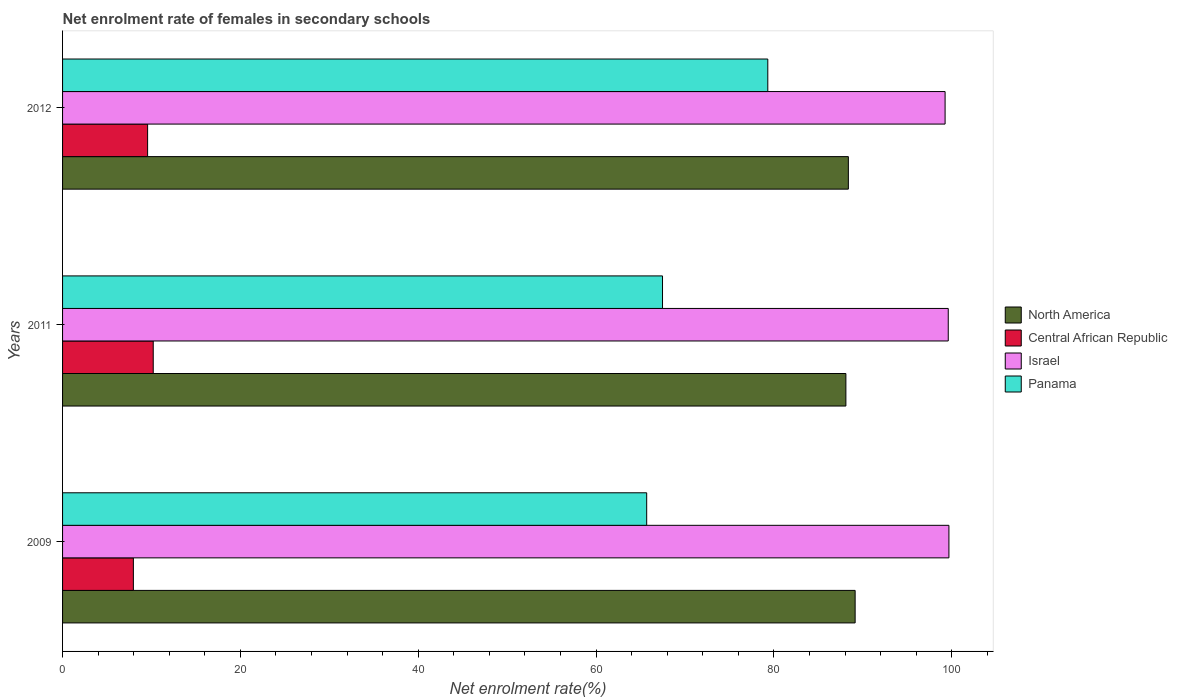How many groups of bars are there?
Your answer should be very brief. 3. Are the number of bars per tick equal to the number of legend labels?
Offer a very short reply. Yes. Are the number of bars on each tick of the Y-axis equal?
Offer a very short reply. Yes. How many bars are there on the 3rd tick from the top?
Your answer should be compact. 4. How many bars are there on the 2nd tick from the bottom?
Provide a short and direct response. 4. What is the label of the 2nd group of bars from the top?
Offer a very short reply. 2011. In how many cases, is the number of bars for a given year not equal to the number of legend labels?
Your response must be concise. 0. What is the net enrolment rate of females in secondary schools in North America in 2012?
Keep it short and to the point. 88.38. Across all years, what is the maximum net enrolment rate of females in secondary schools in Central African Republic?
Ensure brevity in your answer.  10.2. Across all years, what is the minimum net enrolment rate of females in secondary schools in Israel?
Make the answer very short. 99.26. What is the total net enrolment rate of females in secondary schools in Panama in the graph?
Provide a short and direct response. 212.49. What is the difference between the net enrolment rate of females in secondary schools in North America in 2009 and that in 2012?
Ensure brevity in your answer.  0.76. What is the difference between the net enrolment rate of females in secondary schools in Israel in 2009 and the net enrolment rate of females in secondary schools in North America in 2012?
Ensure brevity in your answer.  11.31. What is the average net enrolment rate of females in secondary schools in Central African Republic per year?
Keep it short and to the point. 9.24. In the year 2011, what is the difference between the net enrolment rate of females in secondary schools in North America and net enrolment rate of females in secondary schools in Central African Republic?
Your answer should be compact. 77.9. In how many years, is the net enrolment rate of females in secondary schools in Central African Republic greater than 40 %?
Give a very brief answer. 0. What is the ratio of the net enrolment rate of females in secondary schools in North America in 2011 to that in 2012?
Provide a succinct answer. 1. Is the net enrolment rate of females in secondary schools in Panama in 2011 less than that in 2012?
Ensure brevity in your answer.  Yes. Is the difference between the net enrolment rate of females in secondary schools in North America in 2011 and 2012 greater than the difference between the net enrolment rate of females in secondary schools in Central African Republic in 2011 and 2012?
Keep it short and to the point. No. What is the difference between the highest and the second highest net enrolment rate of females in secondary schools in Panama?
Your answer should be compact. 11.84. What is the difference between the highest and the lowest net enrolment rate of females in secondary schools in North America?
Provide a short and direct response. 1.04. Is it the case that in every year, the sum of the net enrolment rate of females in secondary schools in Israel and net enrolment rate of females in secondary schools in Central African Republic is greater than the sum of net enrolment rate of females in secondary schools in North America and net enrolment rate of females in secondary schools in Panama?
Offer a terse response. Yes. Is it the case that in every year, the sum of the net enrolment rate of females in secondary schools in Central African Republic and net enrolment rate of females in secondary schools in Panama is greater than the net enrolment rate of females in secondary schools in Israel?
Keep it short and to the point. No. How many bars are there?
Make the answer very short. 12. What is the difference between two consecutive major ticks on the X-axis?
Your answer should be very brief. 20. Are the values on the major ticks of X-axis written in scientific E-notation?
Make the answer very short. No. Does the graph contain grids?
Keep it short and to the point. No. How many legend labels are there?
Your answer should be very brief. 4. What is the title of the graph?
Make the answer very short. Net enrolment rate of females in secondary schools. What is the label or title of the X-axis?
Ensure brevity in your answer.  Net enrolment rate(%). What is the label or title of the Y-axis?
Provide a succinct answer. Years. What is the Net enrolment rate(%) in North America in 2009?
Provide a succinct answer. 89.14. What is the Net enrolment rate(%) of Central African Republic in 2009?
Make the answer very short. 7.96. What is the Net enrolment rate(%) in Israel in 2009?
Keep it short and to the point. 99.69. What is the Net enrolment rate(%) in Panama in 2009?
Offer a terse response. 65.7. What is the Net enrolment rate(%) in North America in 2011?
Give a very brief answer. 88.1. What is the Net enrolment rate(%) of Central African Republic in 2011?
Your answer should be very brief. 10.2. What is the Net enrolment rate(%) in Israel in 2011?
Your answer should be compact. 99.61. What is the Net enrolment rate(%) of Panama in 2011?
Offer a terse response. 67.48. What is the Net enrolment rate(%) of North America in 2012?
Your answer should be compact. 88.38. What is the Net enrolment rate(%) of Central African Republic in 2012?
Offer a very short reply. 9.57. What is the Net enrolment rate(%) in Israel in 2012?
Offer a terse response. 99.26. What is the Net enrolment rate(%) of Panama in 2012?
Offer a very short reply. 79.32. Across all years, what is the maximum Net enrolment rate(%) of North America?
Keep it short and to the point. 89.14. Across all years, what is the maximum Net enrolment rate(%) of Central African Republic?
Keep it short and to the point. 10.2. Across all years, what is the maximum Net enrolment rate(%) of Israel?
Offer a terse response. 99.69. Across all years, what is the maximum Net enrolment rate(%) of Panama?
Keep it short and to the point. 79.32. Across all years, what is the minimum Net enrolment rate(%) in North America?
Your answer should be compact. 88.1. Across all years, what is the minimum Net enrolment rate(%) of Central African Republic?
Provide a succinct answer. 7.96. Across all years, what is the minimum Net enrolment rate(%) of Israel?
Offer a very short reply. 99.26. Across all years, what is the minimum Net enrolment rate(%) in Panama?
Your answer should be compact. 65.7. What is the total Net enrolment rate(%) in North America in the graph?
Provide a succinct answer. 265.62. What is the total Net enrolment rate(%) in Central African Republic in the graph?
Your answer should be compact. 27.73. What is the total Net enrolment rate(%) of Israel in the graph?
Make the answer very short. 298.56. What is the total Net enrolment rate(%) in Panama in the graph?
Ensure brevity in your answer.  212.49. What is the difference between the Net enrolment rate(%) of North America in 2009 and that in 2011?
Keep it short and to the point. 1.04. What is the difference between the Net enrolment rate(%) of Central African Republic in 2009 and that in 2011?
Offer a very short reply. -2.23. What is the difference between the Net enrolment rate(%) of Israel in 2009 and that in 2011?
Your response must be concise. 0.08. What is the difference between the Net enrolment rate(%) of Panama in 2009 and that in 2011?
Ensure brevity in your answer.  -1.78. What is the difference between the Net enrolment rate(%) in North America in 2009 and that in 2012?
Provide a short and direct response. 0.76. What is the difference between the Net enrolment rate(%) in Central African Republic in 2009 and that in 2012?
Offer a terse response. -1.6. What is the difference between the Net enrolment rate(%) of Israel in 2009 and that in 2012?
Your answer should be compact. 0.43. What is the difference between the Net enrolment rate(%) in Panama in 2009 and that in 2012?
Keep it short and to the point. -13.62. What is the difference between the Net enrolment rate(%) of North America in 2011 and that in 2012?
Keep it short and to the point. -0.28. What is the difference between the Net enrolment rate(%) in Central African Republic in 2011 and that in 2012?
Ensure brevity in your answer.  0.63. What is the difference between the Net enrolment rate(%) of Israel in 2011 and that in 2012?
Ensure brevity in your answer.  0.35. What is the difference between the Net enrolment rate(%) of Panama in 2011 and that in 2012?
Give a very brief answer. -11.84. What is the difference between the Net enrolment rate(%) of North America in 2009 and the Net enrolment rate(%) of Central African Republic in 2011?
Offer a terse response. 78.94. What is the difference between the Net enrolment rate(%) of North America in 2009 and the Net enrolment rate(%) of Israel in 2011?
Provide a succinct answer. -10.47. What is the difference between the Net enrolment rate(%) of North America in 2009 and the Net enrolment rate(%) of Panama in 2011?
Give a very brief answer. 21.66. What is the difference between the Net enrolment rate(%) in Central African Republic in 2009 and the Net enrolment rate(%) in Israel in 2011?
Give a very brief answer. -91.65. What is the difference between the Net enrolment rate(%) in Central African Republic in 2009 and the Net enrolment rate(%) in Panama in 2011?
Give a very brief answer. -59.51. What is the difference between the Net enrolment rate(%) in Israel in 2009 and the Net enrolment rate(%) in Panama in 2011?
Provide a succinct answer. 32.21. What is the difference between the Net enrolment rate(%) in North America in 2009 and the Net enrolment rate(%) in Central African Republic in 2012?
Provide a short and direct response. 79.57. What is the difference between the Net enrolment rate(%) of North America in 2009 and the Net enrolment rate(%) of Israel in 2012?
Offer a very short reply. -10.12. What is the difference between the Net enrolment rate(%) of North America in 2009 and the Net enrolment rate(%) of Panama in 2012?
Offer a terse response. 9.82. What is the difference between the Net enrolment rate(%) of Central African Republic in 2009 and the Net enrolment rate(%) of Israel in 2012?
Ensure brevity in your answer.  -91.29. What is the difference between the Net enrolment rate(%) in Central African Republic in 2009 and the Net enrolment rate(%) in Panama in 2012?
Provide a succinct answer. -71.35. What is the difference between the Net enrolment rate(%) in Israel in 2009 and the Net enrolment rate(%) in Panama in 2012?
Your answer should be very brief. 20.37. What is the difference between the Net enrolment rate(%) of North America in 2011 and the Net enrolment rate(%) of Central African Republic in 2012?
Your response must be concise. 78.53. What is the difference between the Net enrolment rate(%) of North America in 2011 and the Net enrolment rate(%) of Israel in 2012?
Give a very brief answer. -11.16. What is the difference between the Net enrolment rate(%) of North America in 2011 and the Net enrolment rate(%) of Panama in 2012?
Give a very brief answer. 8.78. What is the difference between the Net enrolment rate(%) of Central African Republic in 2011 and the Net enrolment rate(%) of Israel in 2012?
Make the answer very short. -89.06. What is the difference between the Net enrolment rate(%) of Central African Republic in 2011 and the Net enrolment rate(%) of Panama in 2012?
Ensure brevity in your answer.  -69.12. What is the difference between the Net enrolment rate(%) of Israel in 2011 and the Net enrolment rate(%) of Panama in 2012?
Offer a very short reply. 20.29. What is the average Net enrolment rate(%) in North America per year?
Your answer should be very brief. 88.54. What is the average Net enrolment rate(%) of Central African Republic per year?
Provide a short and direct response. 9.24. What is the average Net enrolment rate(%) in Israel per year?
Your answer should be compact. 99.52. What is the average Net enrolment rate(%) in Panama per year?
Make the answer very short. 70.83. In the year 2009, what is the difference between the Net enrolment rate(%) in North America and Net enrolment rate(%) in Central African Republic?
Give a very brief answer. 81.17. In the year 2009, what is the difference between the Net enrolment rate(%) of North America and Net enrolment rate(%) of Israel?
Give a very brief answer. -10.55. In the year 2009, what is the difference between the Net enrolment rate(%) of North America and Net enrolment rate(%) of Panama?
Your response must be concise. 23.44. In the year 2009, what is the difference between the Net enrolment rate(%) in Central African Republic and Net enrolment rate(%) in Israel?
Your answer should be very brief. -91.72. In the year 2009, what is the difference between the Net enrolment rate(%) of Central African Republic and Net enrolment rate(%) of Panama?
Your answer should be very brief. -57.73. In the year 2009, what is the difference between the Net enrolment rate(%) in Israel and Net enrolment rate(%) in Panama?
Your answer should be compact. 33.99. In the year 2011, what is the difference between the Net enrolment rate(%) of North America and Net enrolment rate(%) of Central African Republic?
Your response must be concise. 77.9. In the year 2011, what is the difference between the Net enrolment rate(%) of North America and Net enrolment rate(%) of Israel?
Provide a succinct answer. -11.51. In the year 2011, what is the difference between the Net enrolment rate(%) in North America and Net enrolment rate(%) in Panama?
Make the answer very short. 20.62. In the year 2011, what is the difference between the Net enrolment rate(%) of Central African Republic and Net enrolment rate(%) of Israel?
Offer a terse response. -89.41. In the year 2011, what is the difference between the Net enrolment rate(%) of Central African Republic and Net enrolment rate(%) of Panama?
Keep it short and to the point. -57.28. In the year 2011, what is the difference between the Net enrolment rate(%) of Israel and Net enrolment rate(%) of Panama?
Keep it short and to the point. 32.14. In the year 2012, what is the difference between the Net enrolment rate(%) of North America and Net enrolment rate(%) of Central African Republic?
Provide a succinct answer. 78.81. In the year 2012, what is the difference between the Net enrolment rate(%) in North America and Net enrolment rate(%) in Israel?
Your response must be concise. -10.88. In the year 2012, what is the difference between the Net enrolment rate(%) in North America and Net enrolment rate(%) in Panama?
Ensure brevity in your answer.  9.06. In the year 2012, what is the difference between the Net enrolment rate(%) of Central African Republic and Net enrolment rate(%) of Israel?
Offer a very short reply. -89.69. In the year 2012, what is the difference between the Net enrolment rate(%) in Central African Republic and Net enrolment rate(%) in Panama?
Keep it short and to the point. -69.75. In the year 2012, what is the difference between the Net enrolment rate(%) of Israel and Net enrolment rate(%) of Panama?
Keep it short and to the point. 19.94. What is the ratio of the Net enrolment rate(%) in North America in 2009 to that in 2011?
Give a very brief answer. 1.01. What is the ratio of the Net enrolment rate(%) in Central African Republic in 2009 to that in 2011?
Offer a terse response. 0.78. What is the ratio of the Net enrolment rate(%) in Panama in 2009 to that in 2011?
Make the answer very short. 0.97. What is the ratio of the Net enrolment rate(%) in North America in 2009 to that in 2012?
Make the answer very short. 1.01. What is the ratio of the Net enrolment rate(%) of Central African Republic in 2009 to that in 2012?
Offer a terse response. 0.83. What is the ratio of the Net enrolment rate(%) of Panama in 2009 to that in 2012?
Provide a short and direct response. 0.83. What is the ratio of the Net enrolment rate(%) of Central African Republic in 2011 to that in 2012?
Ensure brevity in your answer.  1.07. What is the ratio of the Net enrolment rate(%) of Panama in 2011 to that in 2012?
Offer a terse response. 0.85. What is the difference between the highest and the second highest Net enrolment rate(%) of North America?
Offer a very short reply. 0.76. What is the difference between the highest and the second highest Net enrolment rate(%) in Central African Republic?
Your answer should be very brief. 0.63. What is the difference between the highest and the second highest Net enrolment rate(%) of Israel?
Make the answer very short. 0.08. What is the difference between the highest and the second highest Net enrolment rate(%) in Panama?
Your answer should be compact. 11.84. What is the difference between the highest and the lowest Net enrolment rate(%) of North America?
Provide a succinct answer. 1.04. What is the difference between the highest and the lowest Net enrolment rate(%) in Central African Republic?
Make the answer very short. 2.23. What is the difference between the highest and the lowest Net enrolment rate(%) of Israel?
Offer a very short reply. 0.43. What is the difference between the highest and the lowest Net enrolment rate(%) of Panama?
Provide a short and direct response. 13.62. 